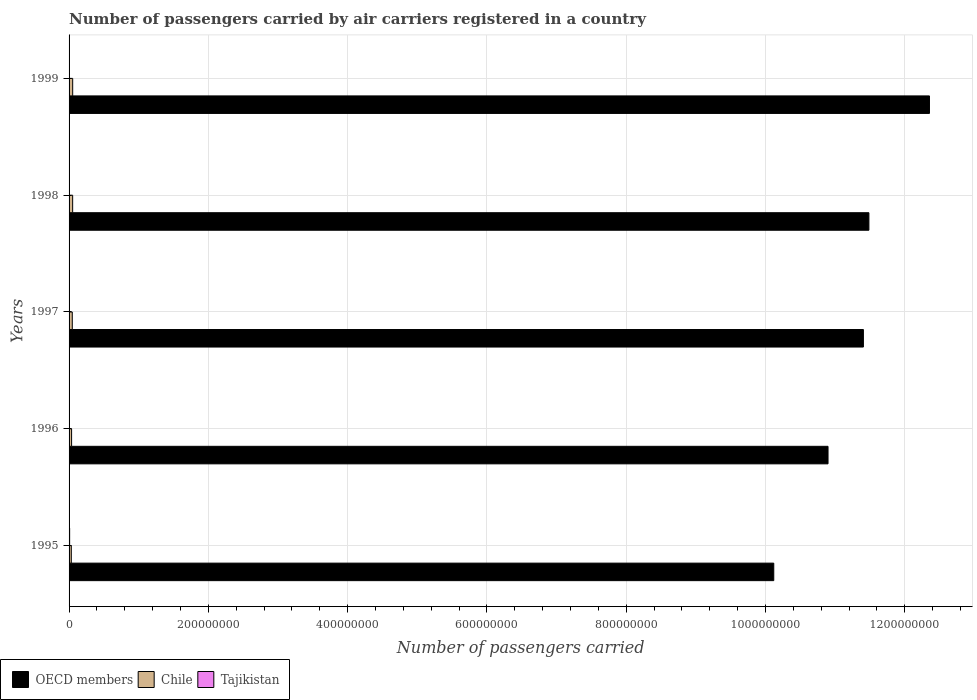Are the number of bars on each tick of the Y-axis equal?
Your response must be concise. Yes. How many bars are there on the 4th tick from the bottom?
Offer a terse response. 3. What is the label of the 2nd group of bars from the top?
Keep it short and to the point. 1998. In how many cases, is the number of bars for a given year not equal to the number of legend labels?
Give a very brief answer. 0. What is the number of passengers carried by air carriers in Chile in 1997?
Give a very brief answer. 4.61e+06. Across all years, what is the maximum number of passengers carried by air carriers in Chile?
Your answer should be very brief. 5.19e+06. Across all years, what is the minimum number of passengers carried by air carriers in OECD members?
Make the answer very short. 1.01e+09. In which year was the number of passengers carried by air carriers in Tajikistan maximum?
Ensure brevity in your answer.  1995. In which year was the number of passengers carried by air carriers in Tajikistan minimum?
Make the answer very short. 1999. What is the total number of passengers carried by air carriers in Chile in the graph?
Keep it short and to the point. 2.18e+07. What is the difference between the number of passengers carried by air carriers in OECD members in 1995 and that in 1996?
Your answer should be compact. -7.79e+07. What is the difference between the number of passengers carried by air carriers in OECD members in 1996 and the number of passengers carried by air carriers in Tajikistan in 1995?
Offer a very short reply. 1.09e+09. What is the average number of passengers carried by air carriers in Tajikistan per year?
Make the answer very short. 5.52e+05. In the year 1996, what is the difference between the number of passengers carried by air carriers in Chile and number of passengers carried by air carriers in Tajikistan?
Ensure brevity in your answer.  3.03e+06. What is the ratio of the number of passengers carried by air carriers in OECD members in 1998 to that in 1999?
Provide a succinct answer. 0.93. Is the difference between the number of passengers carried by air carriers in Chile in 1995 and 1999 greater than the difference between the number of passengers carried by air carriers in Tajikistan in 1995 and 1999?
Offer a very short reply. No. What is the difference between the highest and the second highest number of passengers carried by air carriers in Tajikistan?
Provide a succinct answer. 2.28e+05. What is the difference between the highest and the lowest number of passengers carried by air carriers in Tajikistan?
Give a very brief answer. 6.66e+05. In how many years, is the number of passengers carried by air carriers in Tajikistan greater than the average number of passengers carried by air carriers in Tajikistan taken over all years?
Ensure brevity in your answer.  4. Is the sum of the number of passengers carried by air carriers in Chile in 1995 and 1997 greater than the maximum number of passengers carried by air carriers in Tajikistan across all years?
Give a very brief answer. Yes. What does the 1st bar from the top in 1999 represents?
Your answer should be compact. Tajikistan. What does the 2nd bar from the bottom in 1996 represents?
Your answer should be compact. Chile. How many bars are there?
Ensure brevity in your answer.  15. Are all the bars in the graph horizontal?
Your answer should be compact. Yes. How many years are there in the graph?
Keep it short and to the point. 5. Does the graph contain any zero values?
Provide a succinct answer. No. Does the graph contain grids?
Offer a very short reply. Yes. How are the legend labels stacked?
Provide a short and direct response. Horizontal. What is the title of the graph?
Offer a terse response. Number of passengers carried by air carriers registered in a country. Does "Suriname" appear as one of the legend labels in the graph?
Make the answer very short. No. What is the label or title of the X-axis?
Your answer should be compact. Number of passengers carried. What is the label or title of the Y-axis?
Give a very brief answer. Years. What is the Number of passengers carried in OECD members in 1995?
Your response must be concise. 1.01e+09. What is the Number of passengers carried in Chile in 1995?
Offer a very short reply. 3.20e+06. What is the Number of passengers carried in Tajikistan in 1995?
Provide a short and direct response. 8.22e+05. What is the Number of passengers carried of OECD members in 1996?
Give a very brief answer. 1.09e+09. What is the Number of passengers carried in Chile in 1996?
Make the answer very short. 3.62e+06. What is the Number of passengers carried in Tajikistan in 1996?
Offer a terse response. 5.94e+05. What is the Number of passengers carried of OECD members in 1997?
Make the answer very short. 1.14e+09. What is the Number of passengers carried of Chile in 1997?
Ensure brevity in your answer.  4.61e+06. What is the Number of passengers carried of Tajikistan in 1997?
Provide a succinct answer. 5.94e+05. What is the Number of passengers carried of OECD members in 1998?
Your response must be concise. 1.15e+09. What is the Number of passengers carried in Chile in 1998?
Keep it short and to the point. 5.15e+06. What is the Number of passengers carried of Tajikistan in 1998?
Make the answer very short. 5.92e+05. What is the Number of passengers carried in OECD members in 1999?
Give a very brief answer. 1.24e+09. What is the Number of passengers carried in Chile in 1999?
Make the answer very short. 5.19e+06. What is the Number of passengers carried of Tajikistan in 1999?
Provide a short and direct response. 1.56e+05. Across all years, what is the maximum Number of passengers carried in OECD members?
Your answer should be very brief. 1.24e+09. Across all years, what is the maximum Number of passengers carried in Chile?
Your answer should be compact. 5.19e+06. Across all years, what is the maximum Number of passengers carried of Tajikistan?
Make the answer very short. 8.22e+05. Across all years, what is the minimum Number of passengers carried in OECD members?
Offer a very short reply. 1.01e+09. Across all years, what is the minimum Number of passengers carried of Chile?
Your response must be concise. 3.20e+06. Across all years, what is the minimum Number of passengers carried in Tajikistan?
Your answer should be compact. 1.56e+05. What is the total Number of passengers carried in OECD members in the graph?
Your answer should be compact. 5.63e+09. What is the total Number of passengers carried in Chile in the graph?
Your answer should be very brief. 2.18e+07. What is the total Number of passengers carried in Tajikistan in the graph?
Provide a succinct answer. 2.76e+06. What is the difference between the Number of passengers carried in OECD members in 1995 and that in 1996?
Your response must be concise. -7.79e+07. What is the difference between the Number of passengers carried in Chile in 1995 and that in 1996?
Offer a very short reply. -4.25e+05. What is the difference between the Number of passengers carried in Tajikistan in 1995 and that in 1996?
Offer a very short reply. 2.28e+05. What is the difference between the Number of passengers carried in OECD members in 1995 and that in 1997?
Provide a short and direct response. -1.29e+08. What is the difference between the Number of passengers carried in Chile in 1995 and that in 1997?
Keep it short and to the point. -1.41e+06. What is the difference between the Number of passengers carried in Tajikistan in 1995 and that in 1997?
Give a very brief answer. 2.28e+05. What is the difference between the Number of passengers carried in OECD members in 1995 and that in 1998?
Your answer should be very brief. -1.37e+08. What is the difference between the Number of passengers carried in Chile in 1995 and that in 1998?
Make the answer very short. -1.95e+06. What is the difference between the Number of passengers carried of Tajikistan in 1995 and that in 1998?
Give a very brief answer. 2.30e+05. What is the difference between the Number of passengers carried of OECD members in 1995 and that in 1999?
Your answer should be very brief. -2.24e+08. What is the difference between the Number of passengers carried of Chile in 1995 and that in 1999?
Keep it short and to the point. -1.99e+06. What is the difference between the Number of passengers carried of Tajikistan in 1995 and that in 1999?
Offer a very short reply. 6.66e+05. What is the difference between the Number of passengers carried of OECD members in 1996 and that in 1997?
Your answer should be very brief. -5.08e+07. What is the difference between the Number of passengers carried in Chile in 1996 and that in 1997?
Your answer should be compact. -9.88e+05. What is the difference between the Number of passengers carried in Tajikistan in 1996 and that in 1997?
Keep it short and to the point. 0. What is the difference between the Number of passengers carried in OECD members in 1996 and that in 1998?
Make the answer very short. -5.87e+07. What is the difference between the Number of passengers carried of Chile in 1996 and that in 1998?
Your answer should be compact. -1.53e+06. What is the difference between the Number of passengers carried in Tajikistan in 1996 and that in 1998?
Your answer should be compact. 2300. What is the difference between the Number of passengers carried of OECD members in 1996 and that in 1999?
Offer a terse response. -1.46e+08. What is the difference between the Number of passengers carried in Chile in 1996 and that in 1999?
Provide a short and direct response. -1.57e+06. What is the difference between the Number of passengers carried of Tajikistan in 1996 and that in 1999?
Make the answer very short. 4.38e+05. What is the difference between the Number of passengers carried of OECD members in 1997 and that in 1998?
Give a very brief answer. -7.89e+06. What is the difference between the Number of passengers carried in Chile in 1997 and that in 1998?
Your answer should be compact. -5.40e+05. What is the difference between the Number of passengers carried in Tajikistan in 1997 and that in 1998?
Offer a very short reply. 2300. What is the difference between the Number of passengers carried in OECD members in 1997 and that in 1999?
Offer a very short reply. -9.49e+07. What is the difference between the Number of passengers carried of Chile in 1997 and that in 1999?
Your answer should be very brief. -5.78e+05. What is the difference between the Number of passengers carried of Tajikistan in 1997 and that in 1999?
Provide a short and direct response. 4.38e+05. What is the difference between the Number of passengers carried of OECD members in 1998 and that in 1999?
Keep it short and to the point. -8.70e+07. What is the difference between the Number of passengers carried in Chile in 1998 and that in 1999?
Provide a succinct answer. -3.79e+04. What is the difference between the Number of passengers carried of Tajikistan in 1998 and that in 1999?
Keep it short and to the point. 4.36e+05. What is the difference between the Number of passengers carried in OECD members in 1995 and the Number of passengers carried in Chile in 1996?
Keep it short and to the point. 1.01e+09. What is the difference between the Number of passengers carried of OECD members in 1995 and the Number of passengers carried of Tajikistan in 1996?
Provide a succinct answer. 1.01e+09. What is the difference between the Number of passengers carried in Chile in 1995 and the Number of passengers carried in Tajikistan in 1996?
Provide a short and direct response. 2.60e+06. What is the difference between the Number of passengers carried of OECD members in 1995 and the Number of passengers carried of Chile in 1997?
Make the answer very short. 1.01e+09. What is the difference between the Number of passengers carried of OECD members in 1995 and the Number of passengers carried of Tajikistan in 1997?
Your answer should be very brief. 1.01e+09. What is the difference between the Number of passengers carried in Chile in 1995 and the Number of passengers carried in Tajikistan in 1997?
Ensure brevity in your answer.  2.60e+06. What is the difference between the Number of passengers carried of OECD members in 1995 and the Number of passengers carried of Chile in 1998?
Provide a succinct answer. 1.01e+09. What is the difference between the Number of passengers carried in OECD members in 1995 and the Number of passengers carried in Tajikistan in 1998?
Offer a terse response. 1.01e+09. What is the difference between the Number of passengers carried in Chile in 1995 and the Number of passengers carried in Tajikistan in 1998?
Provide a short and direct response. 2.61e+06. What is the difference between the Number of passengers carried of OECD members in 1995 and the Number of passengers carried of Chile in 1999?
Provide a short and direct response. 1.01e+09. What is the difference between the Number of passengers carried of OECD members in 1995 and the Number of passengers carried of Tajikistan in 1999?
Provide a succinct answer. 1.01e+09. What is the difference between the Number of passengers carried of Chile in 1995 and the Number of passengers carried of Tajikistan in 1999?
Your response must be concise. 3.04e+06. What is the difference between the Number of passengers carried of OECD members in 1996 and the Number of passengers carried of Chile in 1997?
Offer a terse response. 1.09e+09. What is the difference between the Number of passengers carried of OECD members in 1996 and the Number of passengers carried of Tajikistan in 1997?
Provide a short and direct response. 1.09e+09. What is the difference between the Number of passengers carried of Chile in 1996 and the Number of passengers carried of Tajikistan in 1997?
Keep it short and to the point. 3.03e+06. What is the difference between the Number of passengers carried of OECD members in 1996 and the Number of passengers carried of Chile in 1998?
Offer a terse response. 1.08e+09. What is the difference between the Number of passengers carried of OECD members in 1996 and the Number of passengers carried of Tajikistan in 1998?
Your answer should be very brief. 1.09e+09. What is the difference between the Number of passengers carried of Chile in 1996 and the Number of passengers carried of Tajikistan in 1998?
Offer a terse response. 3.03e+06. What is the difference between the Number of passengers carried in OECD members in 1996 and the Number of passengers carried in Chile in 1999?
Give a very brief answer. 1.08e+09. What is the difference between the Number of passengers carried in OECD members in 1996 and the Number of passengers carried in Tajikistan in 1999?
Your answer should be compact. 1.09e+09. What is the difference between the Number of passengers carried in Chile in 1996 and the Number of passengers carried in Tajikistan in 1999?
Offer a terse response. 3.47e+06. What is the difference between the Number of passengers carried of OECD members in 1997 and the Number of passengers carried of Chile in 1998?
Keep it short and to the point. 1.14e+09. What is the difference between the Number of passengers carried in OECD members in 1997 and the Number of passengers carried in Tajikistan in 1998?
Offer a terse response. 1.14e+09. What is the difference between the Number of passengers carried in Chile in 1997 and the Number of passengers carried in Tajikistan in 1998?
Keep it short and to the point. 4.02e+06. What is the difference between the Number of passengers carried of OECD members in 1997 and the Number of passengers carried of Chile in 1999?
Offer a terse response. 1.14e+09. What is the difference between the Number of passengers carried of OECD members in 1997 and the Number of passengers carried of Tajikistan in 1999?
Your answer should be very brief. 1.14e+09. What is the difference between the Number of passengers carried of Chile in 1997 and the Number of passengers carried of Tajikistan in 1999?
Ensure brevity in your answer.  4.45e+06. What is the difference between the Number of passengers carried of OECD members in 1998 and the Number of passengers carried of Chile in 1999?
Provide a short and direct response. 1.14e+09. What is the difference between the Number of passengers carried in OECD members in 1998 and the Number of passengers carried in Tajikistan in 1999?
Keep it short and to the point. 1.15e+09. What is the difference between the Number of passengers carried in Chile in 1998 and the Number of passengers carried in Tajikistan in 1999?
Keep it short and to the point. 4.99e+06. What is the average Number of passengers carried in OECD members per year?
Offer a very short reply. 1.13e+09. What is the average Number of passengers carried in Chile per year?
Provide a succinct answer. 4.35e+06. What is the average Number of passengers carried of Tajikistan per year?
Provide a succinct answer. 5.52e+05. In the year 1995, what is the difference between the Number of passengers carried of OECD members and Number of passengers carried of Chile?
Offer a terse response. 1.01e+09. In the year 1995, what is the difference between the Number of passengers carried in OECD members and Number of passengers carried in Tajikistan?
Offer a terse response. 1.01e+09. In the year 1995, what is the difference between the Number of passengers carried of Chile and Number of passengers carried of Tajikistan?
Your response must be concise. 2.38e+06. In the year 1996, what is the difference between the Number of passengers carried in OECD members and Number of passengers carried in Chile?
Your answer should be very brief. 1.09e+09. In the year 1996, what is the difference between the Number of passengers carried in OECD members and Number of passengers carried in Tajikistan?
Offer a terse response. 1.09e+09. In the year 1996, what is the difference between the Number of passengers carried in Chile and Number of passengers carried in Tajikistan?
Your response must be concise. 3.03e+06. In the year 1997, what is the difference between the Number of passengers carried of OECD members and Number of passengers carried of Chile?
Make the answer very short. 1.14e+09. In the year 1997, what is the difference between the Number of passengers carried in OECD members and Number of passengers carried in Tajikistan?
Provide a succinct answer. 1.14e+09. In the year 1997, what is the difference between the Number of passengers carried in Chile and Number of passengers carried in Tajikistan?
Give a very brief answer. 4.02e+06. In the year 1998, what is the difference between the Number of passengers carried of OECD members and Number of passengers carried of Chile?
Provide a short and direct response. 1.14e+09. In the year 1998, what is the difference between the Number of passengers carried in OECD members and Number of passengers carried in Tajikistan?
Keep it short and to the point. 1.15e+09. In the year 1998, what is the difference between the Number of passengers carried in Chile and Number of passengers carried in Tajikistan?
Offer a terse response. 4.56e+06. In the year 1999, what is the difference between the Number of passengers carried of OECD members and Number of passengers carried of Chile?
Offer a very short reply. 1.23e+09. In the year 1999, what is the difference between the Number of passengers carried of OECD members and Number of passengers carried of Tajikistan?
Provide a succinct answer. 1.24e+09. In the year 1999, what is the difference between the Number of passengers carried in Chile and Number of passengers carried in Tajikistan?
Your response must be concise. 5.03e+06. What is the ratio of the Number of passengers carried in OECD members in 1995 to that in 1996?
Provide a succinct answer. 0.93. What is the ratio of the Number of passengers carried in Chile in 1995 to that in 1996?
Your answer should be very brief. 0.88. What is the ratio of the Number of passengers carried in Tajikistan in 1995 to that in 1996?
Your response must be concise. 1.38. What is the ratio of the Number of passengers carried in OECD members in 1995 to that in 1997?
Offer a terse response. 0.89. What is the ratio of the Number of passengers carried in Chile in 1995 to that in 1997?
Your response must be concise. 0.69. What is the ratio of the Number of passengers carried of Tajikistan in 1995 to that in 1997?
Make the answer very short. 1.38. What is the ratio of the Number of passengers carried of OECD members in 1995 to that in 1998?
Make the answer very short. 0.88. What is the ratio of the Number of passengers carried of Chile in 1995 to that in 1998?
Your answer should be compact. 0.62. What is the ratio of the Number of passengers carried in Tajikistan in 1995 to that in 1998?
Provide a short and direct response. 1.39. What is the ratio of the Number of passengers carried of OECD members in 1995 to that in 1999?
Your response must be concise. 0.82. What is the ratio of the Number of passengers carried of Chile in 1995 to that in 1999?
Offer a very short reply. 0.62. What is the ratio of the Number of passengers carried in Tajikistan in 1995 to that in 1999?
Your response must be concise. 5.28. What is the ratio of the Number of passengers carried of OECD members in 1996 to that in 1997?
Your answer should be compact. 0.96. What is the ratio of the Number of passengers carried of Chile in 1996 to that in 1997?
Keep it short and to the point. 0.79. What is the ratio of the Number of passengers carried in OECD members in 1996 to that in 1998?
Give a very brief answer. 0.95. What is the ratio of the Number of passengers carried of Chile in 1996 to that in 1998?
Offer a terse response. 0.7. What is the ratio of the Number of passengers carried in OECD members in 1996 to that in 1999?
Your answer should be compact. 0.88. What is the ratio of the Number of passengers carried in Chile in 1996 to that in 1999?
Your response must be concise. 0.7. What is the ratio of the Number of passengers carried of Tajikistan in 1996 to that in 1999?
Ensure brevity in your answer.  3.81. What is the ratio of the Number of passengers carried of Chile in 1997 to that in 1998?
Provide a succinct answer. 0.9. What is the ratio of the Number of passengers carried in Tajikistan in 1997 to that in 1998?
Keep it short and to the point. 1. What is the ratio of the Number of passengers carried in OECD members in 1997 to that in 1999?
Provide a succinct answer. 0.92. What is the ratio of the Number of passengers carried of Chile in 1997 to that in 1999?
Your answer should be compact. 0.89. What is the ratio of the Number of passengers carried of Tajikistan in 1997 to that in 1999?
Make the answer very short. 3.81. What is the ratio of the Number of passengers carried in OECD members in 1998 to that in 1999?
Provide a short and direct response. 0.93. What is the ratio of the Number of passengers carried of Tajikistan in 1998 to that in 1999?
Ensure brevity in your answer.  3.8. What is the difference between the highest and the second highest Number of passengers carried of OECD members?
Your answer should be very brief. 8.70e+07. What is the difference between the highest and the second highest Number of passengers carried of Chile?
Your answer should be very brief. 3.79e+04. What is the difference between the highest and the second highest Number of passengers carried of Tajikistan?
Your response must be concise. 2.28e+05. What is the difference between the highest and the lowest Number of passengers carried in OECD members?
Make the answer very short. 2.24e+08. What is the difference between the highest and the lowest Number of passengers carried of Chile?
Make the answer very short. 1.99e+06. What is the difference between the highest and the lowest Number of passengers carried of Tajikistan?
Provide a succinct answer. 6.66e+05. 